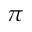<formula> <loc_0><loc_0><loc_500><loc_500>\pi</formula> 